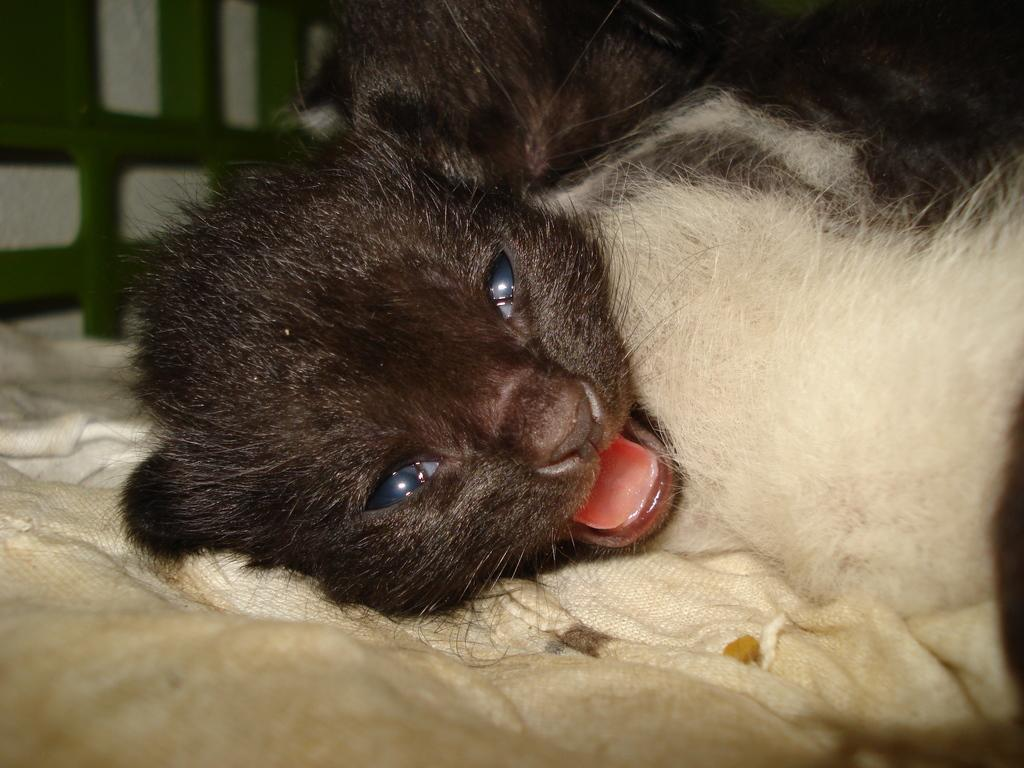What type of animal is in the image? There is a cat in the image. What colors can be seen on the cat? The cat is black and white in color. Where is the cat located in the image? The cat is present on a bed. What type of teeth can be seen in the image? There are no teeth visible in the image, as it features a cat on a bed. What type of land is visible in the image? The image does not show any land; it only features a cat on a bed. 